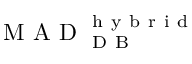Convert formula to latex. <formula><loc_0><loc_0><loc_500><loc_500>M A D _ { D B } ^ { h y b r i d }</formula> 